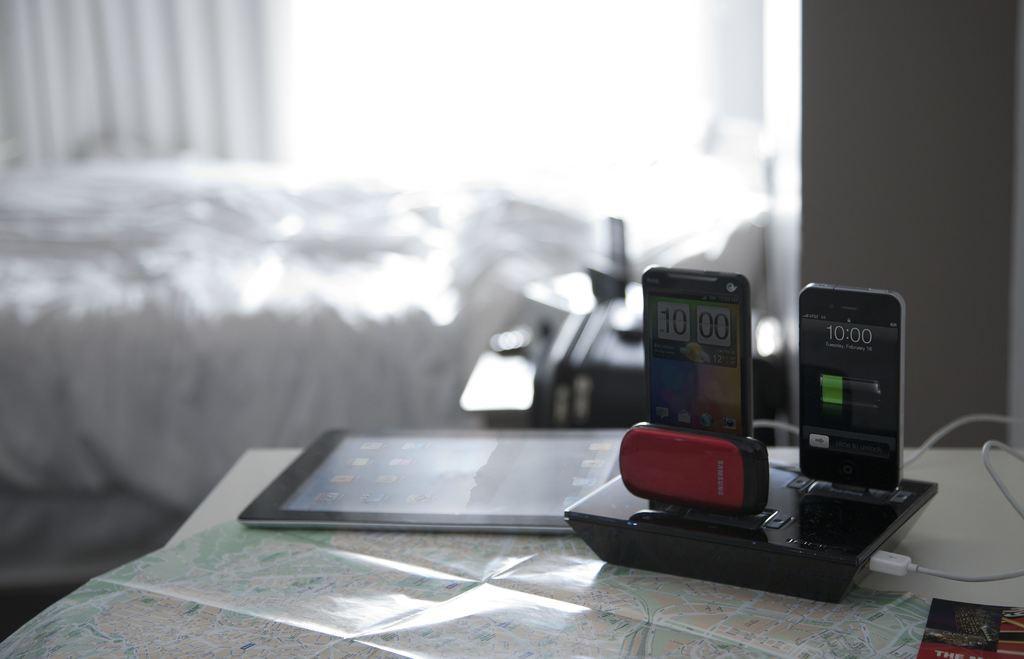Describe this image in one or two sentences. In this image there is a table on which there is a map,tablet and charging port for charging the mobiles. At the background there is a wall. 